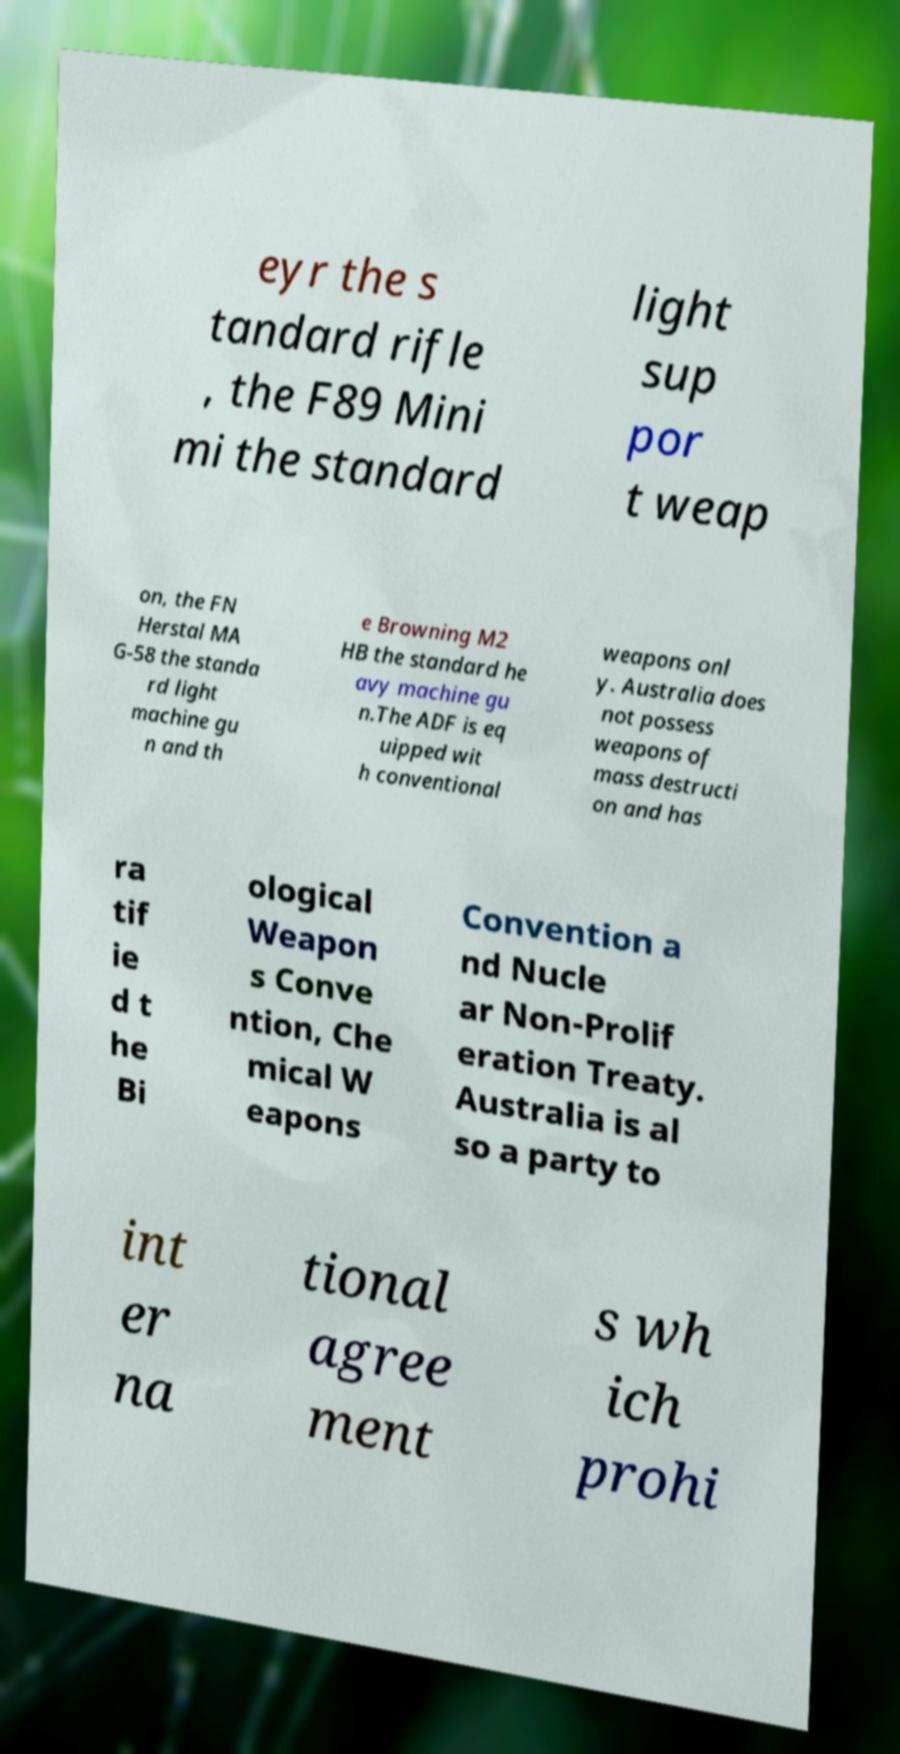Can you read and provide the text displayed in the image?This photo seems to have some interesting text. Can you extract and type it out for me? eyr the s tandard rifle , the F89 Mini mi the standard light sup por t weap on, the FN Herstal MA G-58 the standa rd light machine gu n and th e Browning M2 HB the standard he avy machine gu n.The ADF is eq uipped wit h conventional weapons onl y. Australia does not possess weapons of mass destructi on and has ra tif ie d t he Bi ological Weapon s Conve ntion, Che mical W eapons Convention a nd Nucle ar Non-Prolif eration Treaty. Australia is al so a party to int er na tional agree ment s wh ich prohi 